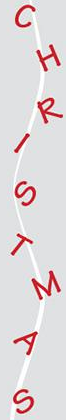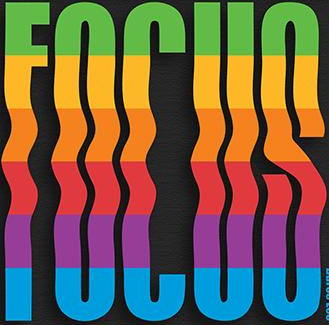Read the text from these images in sequence, separated by a semicolon. CHRISTMAS; FOCUS 